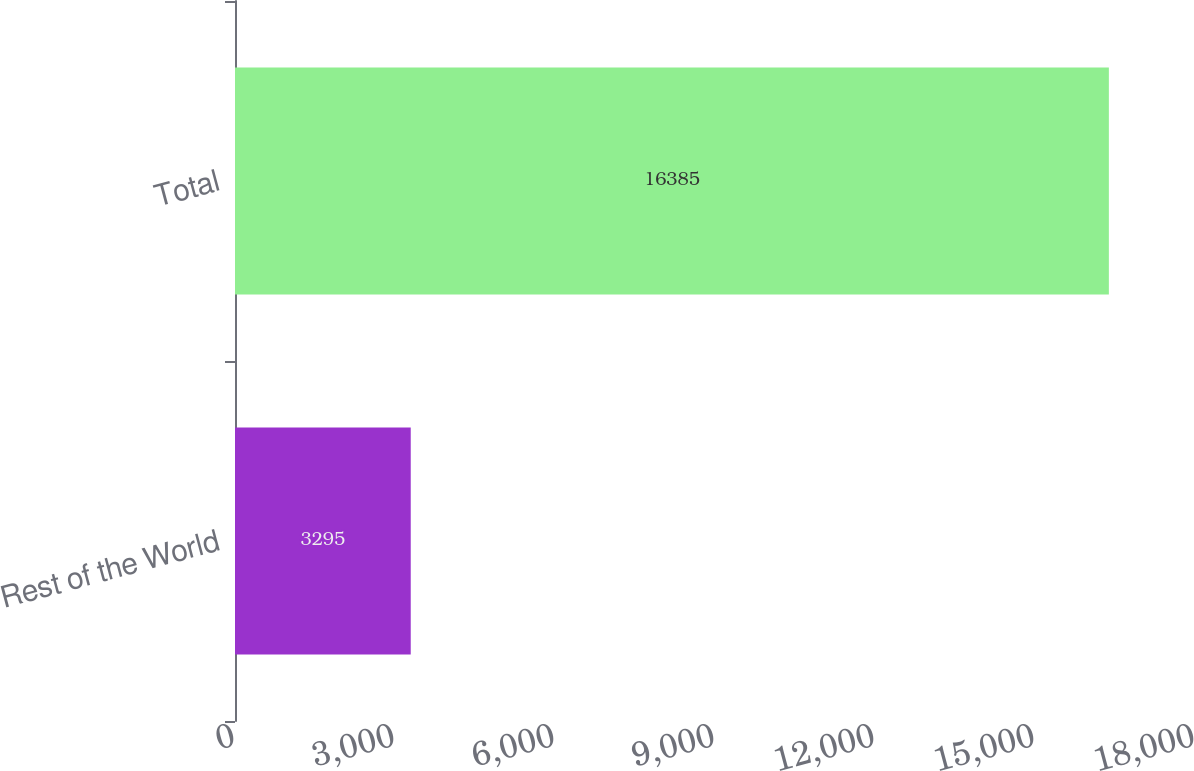Convert chart to OTSL. <chart><loc_0><loc_0><loc_500><loc_500><bar_chart><fcel>Rest of the World<fcel>Total<nl><fcel>3295<fcel>16385<nl></chart> 